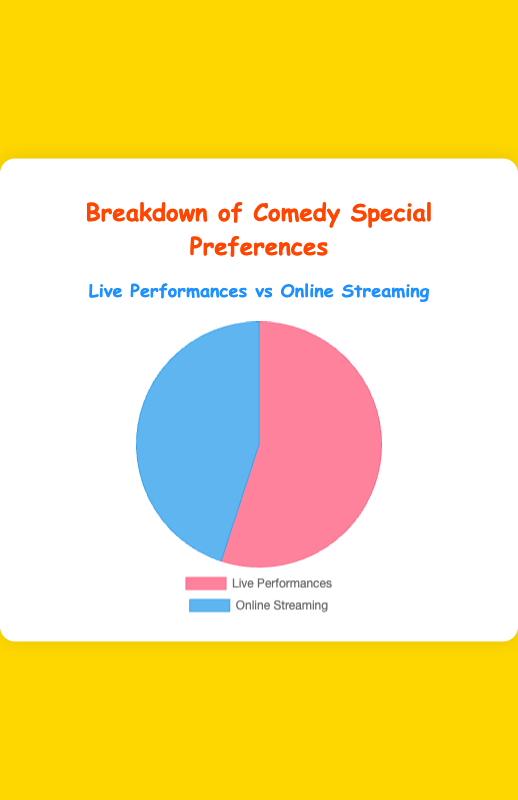What is the preferred method for watching comedy specials according to the chart? According to the chart, 55% of people prefer Live Performances, whereas 45% prefer Online Streaming. Since the percentage for Live Performances is higher, it indicates that Live Performances are the preferred method.
Answer: Live Performances What percentage of people prefer Online Streaming? The chart provides the breakdown of preferences and indicates that 45% of people prefer Online Streaming for comedy specials.
Answer: 45% What is the difference in percentage between Live Performances and Online Streaming preferences? From the chart, we have 55% for Live Performances and 45% for Online Streaming. The difference can be calculated by subtracting 45 from 55.
Answer: 10% Which preference has the higher percentage: Live Performances or Online Streaming? By comparing the two percentages provided in the chart, 55% (Live Performances) and 45% (Online Streaming), Live Performances has the higher percentage.
Answer: Live Performances What are some examples of entities listed under Live Performances? The chart mentions entities such as Aakash Gupta's Live in Mumbai, Biswa Kalyan Rath's Tour, and Kenny Sebastian's Stand-Up Tour as examples of Live Performances.
Answer: Aakash Gupta's Live in Mumbai, Biswa Kalyan Rath's Tour, Kenny Sebastian's Stand-Up Tour What total percentage does the combination of both preferences (Live Performances and Online Streaming) make? The total percentage is the sum of the individual percentages: 55% (Live Performances) + 45% (Online Streaming) = 100%.
Answer: 100% What percentage prefers comedy specials through Online Streaming over Live Performances? Subtract the percentage of those who prefer Online Streaming (45%) from those who prefer Live Performances (55%) to find the percentage that favors Online Streaming less than Live Performances.
Answer: 10% What are some examples of comedy specials available through Online Streaming? The chart lists examples such as Aakash Gupta's Amazon Prime Special, Zakir Khan's Netflix Special, and Vir Das's Comedy Specials on YouTube for Online Streaming preferences.
Answer: Aakash Gupta's Amazon Prime Special, Zakir Khan's Netflix Special, Vir Das's Comedy Specials on YouTube What is the percentage difference between Online Streaming preferences and the total percentage available? The total available percentage is 100%. Subtracting the Online Streaming preference (45%) from 100% gives the difference.
Answer: 55% 